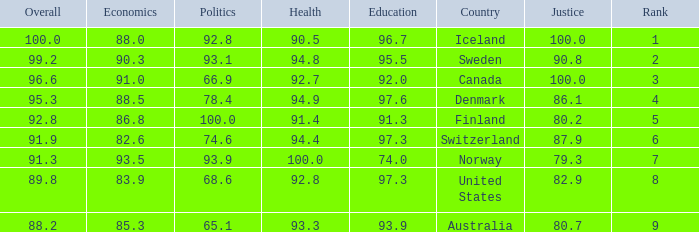What's the country with health being 91.4 Finland. Could you parse the entire table? {'header': ['Overall', 'Economics', 'Politics', 'Health', 'Education', 'Country', 'Justice', 'Rank'], 'rows': [['100.0', '88.0', '92.8', '90.5', '96.7', 'Iceland', '100.0', '1'], ['99.2', '90.3', '93.1', '94.8', '95.5', 'Sweden', '90.8', '2'], ['96.6', '91.0', '66.9', '92.7', '92.0', 'Canada', '100.0', '3'], ['95.3', '88.5', '78.4', '94.9', '97.6', 'Denmark', '86.1', '4'], ['92.8', '86.8', '100.0', '91.4', '91.3', 'Finland', '80.2', '5'], ['91.9', '82.6', '74.6', '94.4', '97.3', 'Switzerland', '87.9', '6'], ['91.3', '93.5', '93.9', '100.0', '74.0', 'Norway', '79.3', '7'], ['89.8', '83.9', '68.6', '92.8', '97.3', 'United States', '82.9', '8'], ['88.2', '85.3', '65.1', '93.3', '93.9', 'Australia', '80.7', '9']]} 